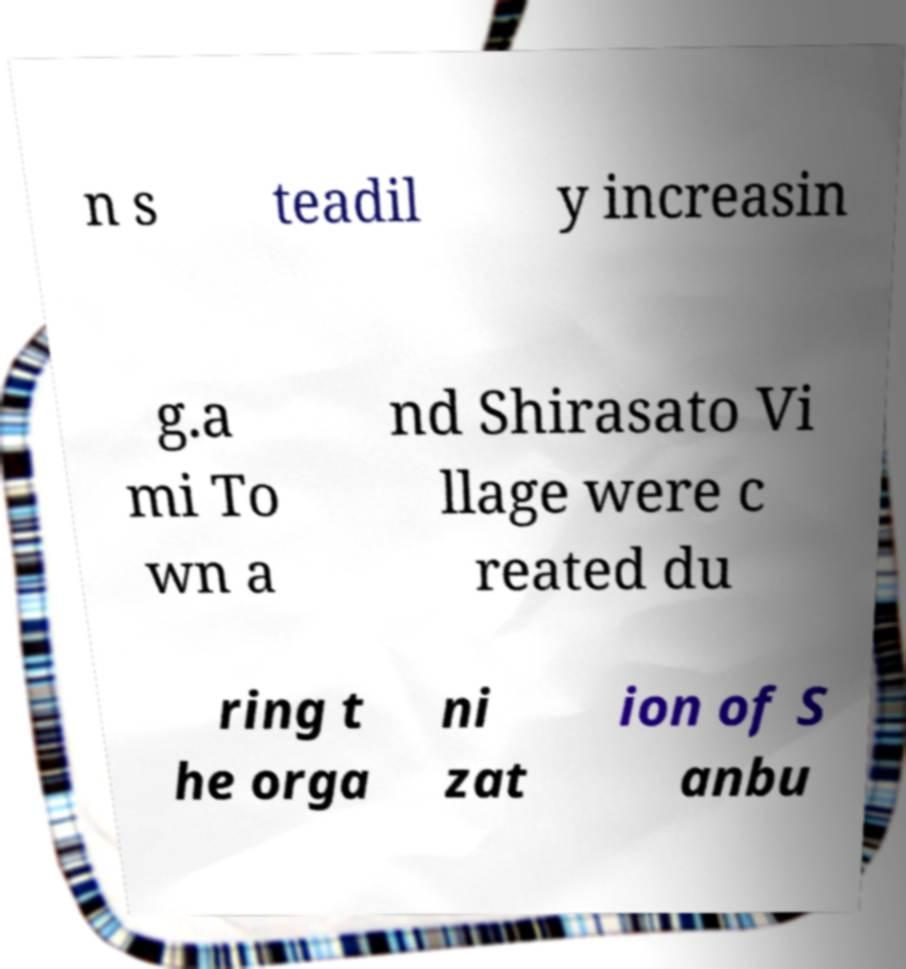Can you read and provide the text displayed in the image?This photo seems to have some interesting text. Can you extract and type it out for me? n s teadil y increasin g.a mi To wn a nd Shirasato Vi llage were c reated du ring t he orga ni zat ion of S anbu 